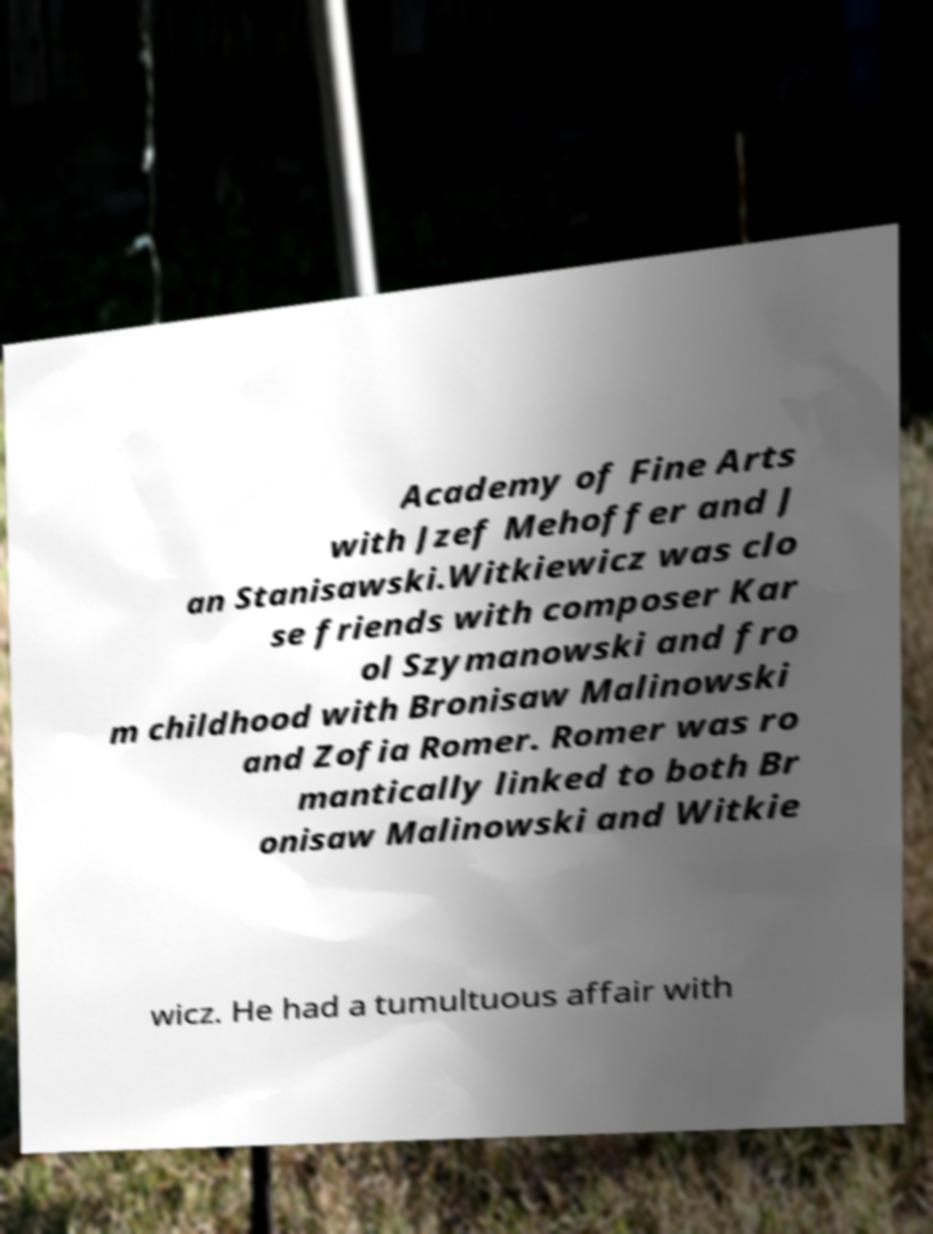Please read and relay the text visible in this image. What does it say? Academy of Fine Arts with Jzef Mehoffer and J an Stanisawski.Witkiewicz was clo se friends with composer Kar ol Szymanowski and fro m childhood with Bronisaw Malinowski and Zofia Romer. Romer was ro mantically linked to both Br onisaw Malinowski and Witkie wicz. He had a tumultuous affair with 